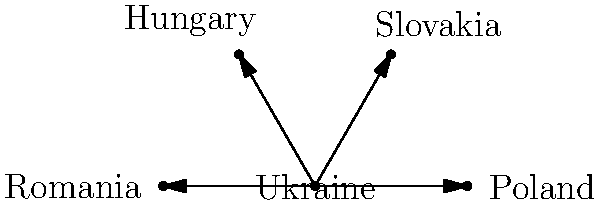Based on the simple map showing refugee routes from Ukraine to neighboring countries, how many direct routes are depicted for Ukrainian refugees to reach neighboring countries? To determine the number of direct routes depicted for Ukrainian refugees to reach neighboring countries, we need to follow these steps:

1. Identify the origin country (Ukraine) on the map.
2. Identify the neighboring countries shown on the map.
3. Count the number of arrows originating from Ukraine and pointing to neighboring countries.

Step 1: Ukraine is clearly labeled and positioned at the center of the map.

Step 2: The neighboring countries shown on the map are:
- Poland
- Slovakia
- Hungary
- Romania

Step 3: Counting the arrows:
- There is an arrow from Ukraine to Poland
- There is an arrow from Ukraine to Slovakia
- There is an arrow from Ukraine to Hungary
- There is an arrow from Ukraine to Romania

By counting these arrows, we can see that there are 4 direct routes depicted on the map for Ukrainian refugees to reach neighboring countries.
Answer: 4 